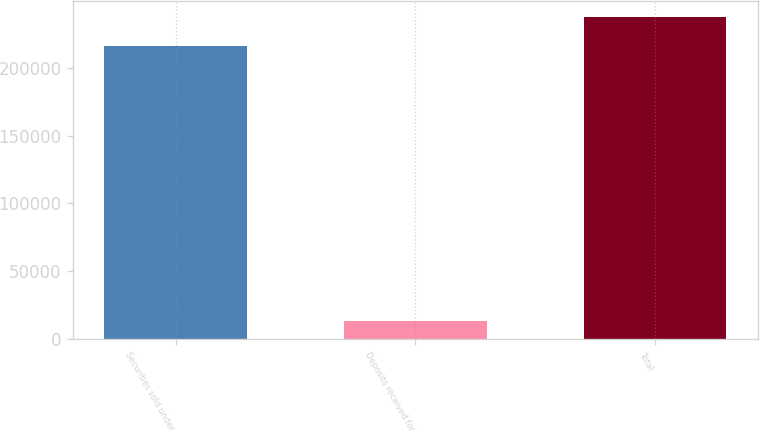Convert chart. <chart><loc_0><loc_0><loc_500><loc_500><bar_chart><fcel>Securities sold under<fcel>Deposits received for<fcel>Total<nl><fcel>216122<fcel>13305<fcel>237734<nl></chart> 